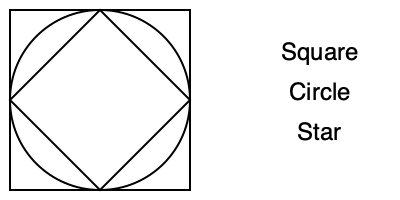Which of the geometric shapes shown in the image is most commonly associated with the concept of unity and oneness in Islamic mosque decorations, and why is it significant in Islamic art? To answer this question, let's consider the symbolic meanings of each shape in Islamic art:

1. Square: Represents stability and earthly elements.
2. Circle: Symbolizes unity, oneness, and eternity.
3. Star: Often represents the spread of Islam or divine guidance.

The circle is the most commonly associated with the concept of unity and oneness in Islamic mosque decorations. Here's why:

1. Symbolic meaning: The circle has no beginning or end, representing the infinite nature of Allah and the unity of all creation.

2. Tawhid: In Islamic theology, the principle of Tawhid (the oneness of God) is fundamental. The circle's perfect form reflects this concept of divine unity.

3. Dome structures: Many mosques feature circular domes, which are not only architectural marvels but also symbolic representations of the heavens and divine unity.

4. Repetition in patterns: Circular motifs are often repeated in intricate geometric patterns, emphasizing the idea of unity through multiplicity.

5. Calligraphy: Circular compositions are common in Islamic calligraphy, especially for writing the name of Allah or important Quranic verses.

The significance of the circle in Islamic art lies in its ability to convey complex theological concepts through a simple, universal form. It serves as a constant reminder of the central Islamic belief in the oneness of God and the unity of all creation.
Answer: Circle; represents unity and oneness of Allah 